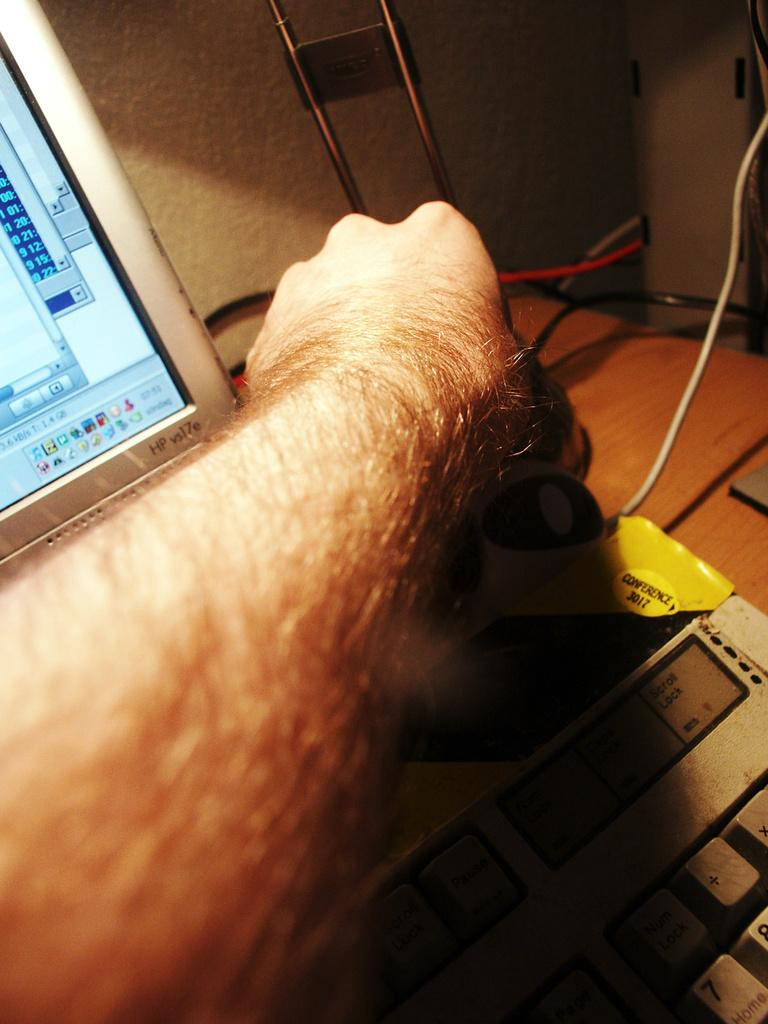<image>
Offer a succinct explanation of the picture presented. A mans arm in front of a HP computer screen 